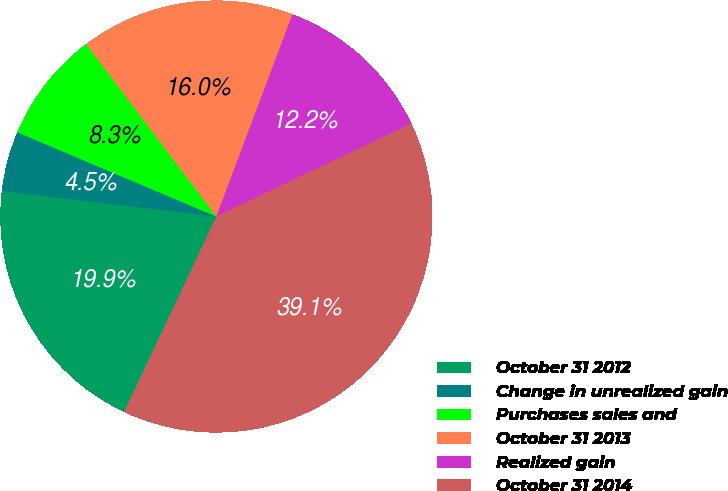Convert chart. <chart><loc_0><loc_0><loc_500><loc_500><pie_chart><fcel>October 31 2012<fcel>Change in unrealized gain<fcel>Purchases sales and<fcel>October 31 2013<fcel>Realized gain<fcel>October 31 2014<nl><fcel>19.87%<fcel>4.49%<fcel>8.33%<fcel>16.03%<fcel>12.18%<fcel>39.1%<nl></chart> 